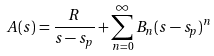Convert formula to latex. <formula><loc_0><loc_0><loc_500><loc_500>A ( s ) = \frac { R } { s - s _ { p } } + \sum _ { n = 0 } ^ { \infty } B _ { n } ( s - s _ { p } ) ^ { n }</formula> 